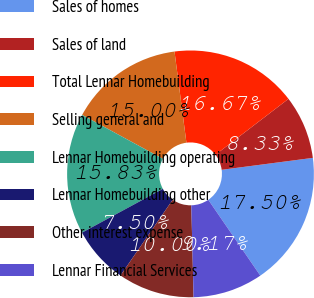Convert chart to OTSL. <chart><loc_0><loc_0><loc_500><loc_500><pie_chart><fcel>Sales of homes<fcel>Sales of land<fcel>Total Lennar Homebuilding<fcel>Selling general and<fcel>Lennar Homebuilding operating<fcel>Lennar Homebuilding other<fcel>Other interest expense<fcel>Lennar Financial Services<nl><fcel>17.5%<fcel>8.33%<fcel>16.67%<fcel>15.0%<fcel>15.83%<fcel>7.5%<fcel>10.0%<fcel>9.17%<nl></chart> 